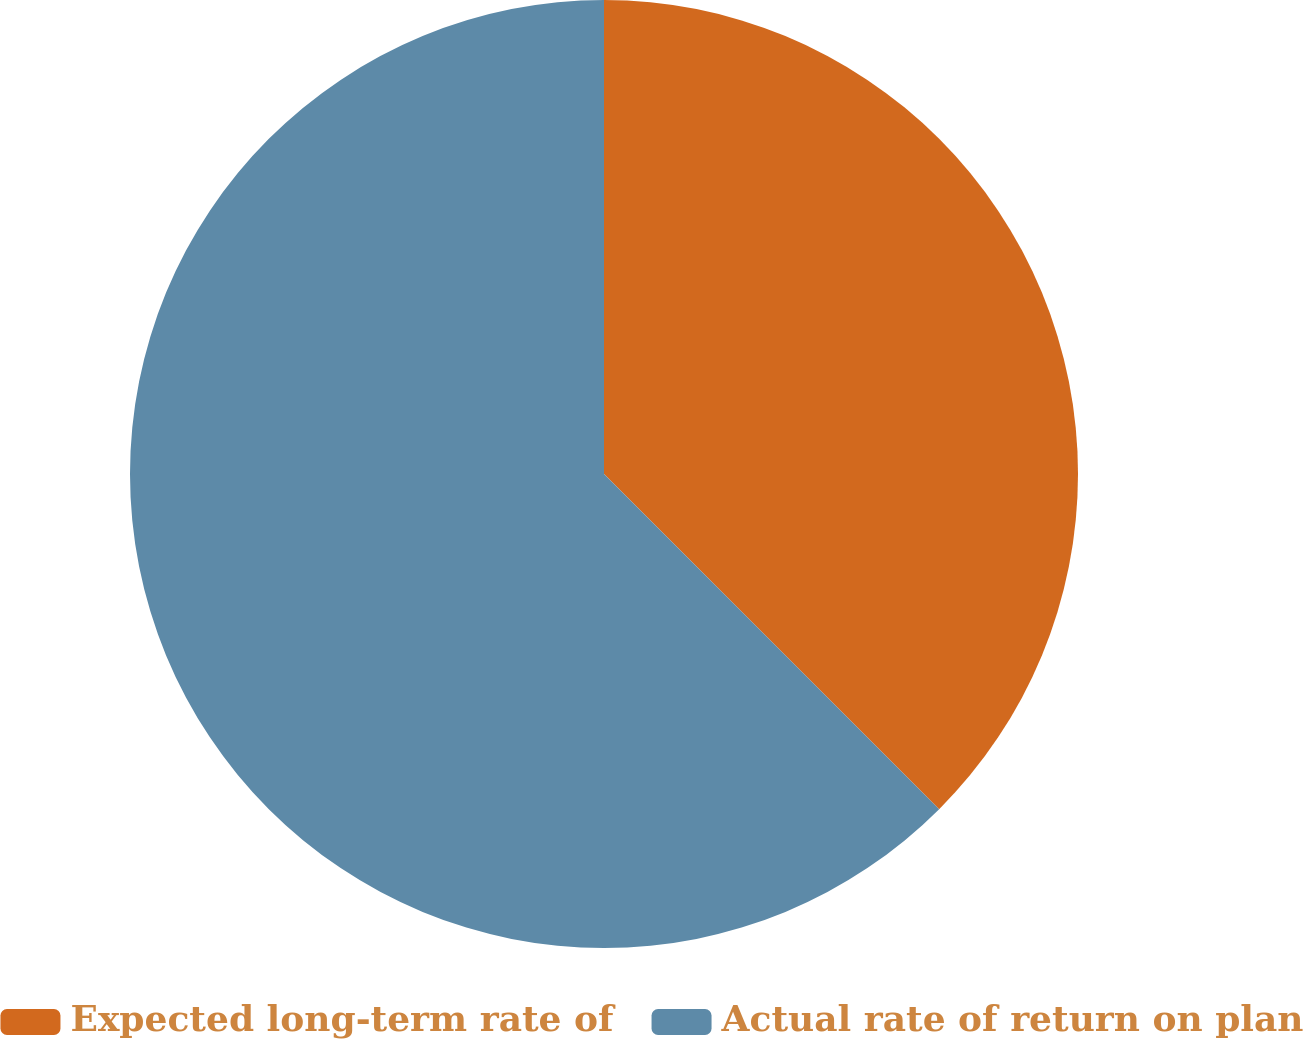Convert chart. <chart><loc_0><loc_0><loc_500><loc_500><pie_chart><fcel>Expected long-term rate of<fcel>Actual rate of return on plan<nl><fcel>37.5%<fcel>62.5%<nl></chart> 